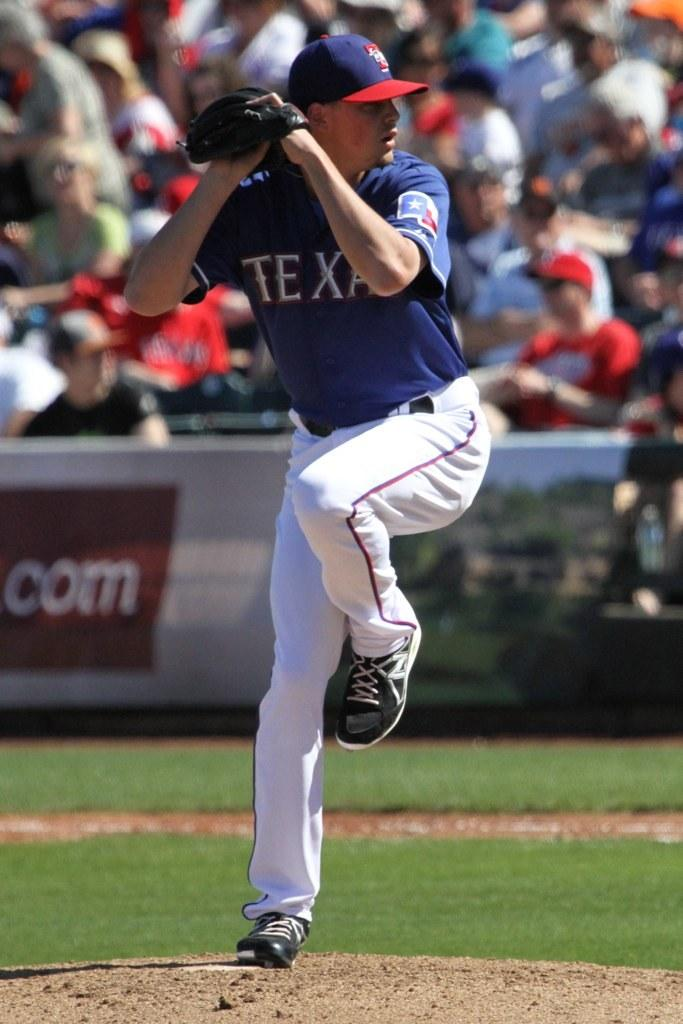Provide a one-sentence caption for the provided image. Baseball pitcher from the team Texas ready to throw the ball. 